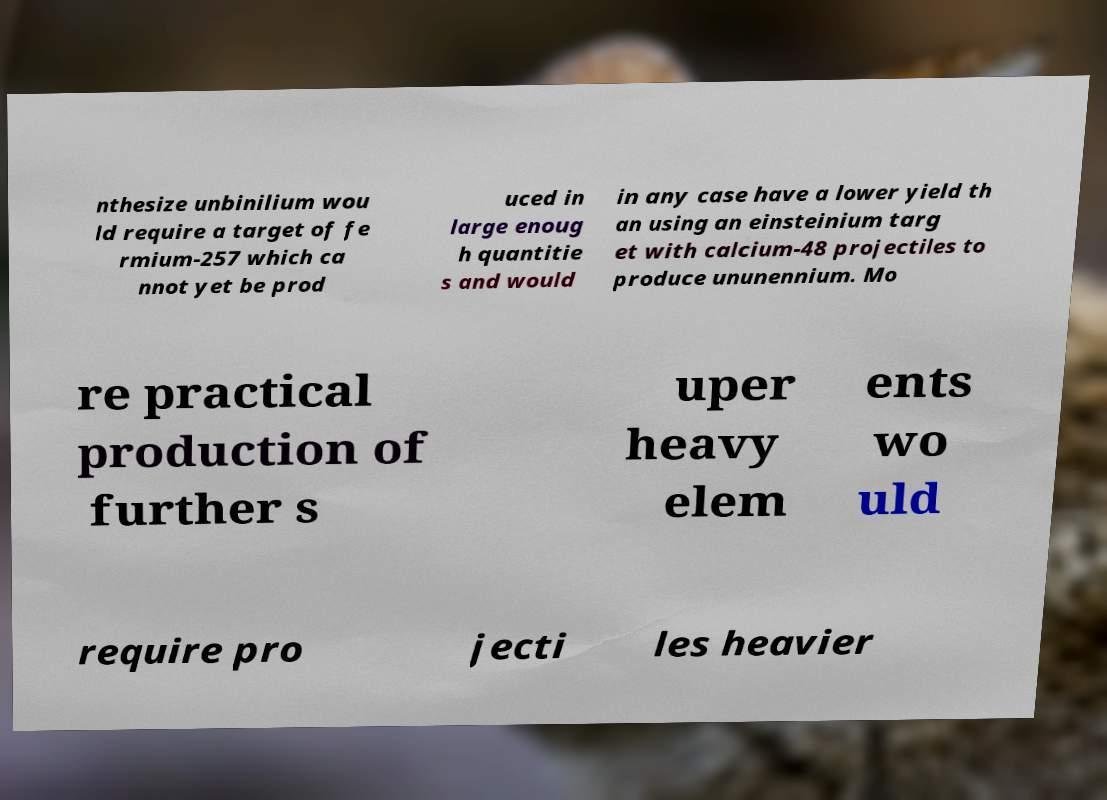What messages or text are displayed in this image? I need them in a readable, typed format. nthesize unbinilium wou ld require a target of fe rmium-257 which ca nnot yet be prod uced in large enoug h quantitie s and would in any case have a lower yield th an using an einsteinium targ et with calcium-48 projectiles to produce ununennium. Mo re practical production of further s uper heavy elem ents wo uld require pro jecti les heavier 